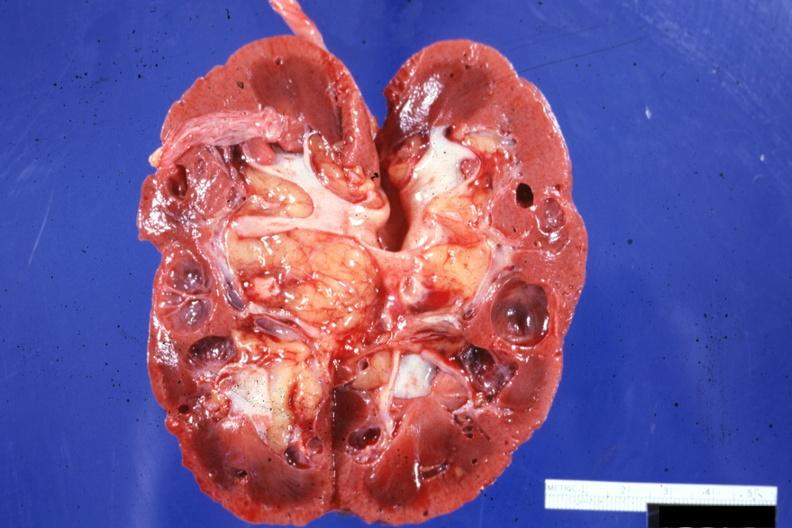what is present?
Answer the question using a single word or phrase. Kidney 